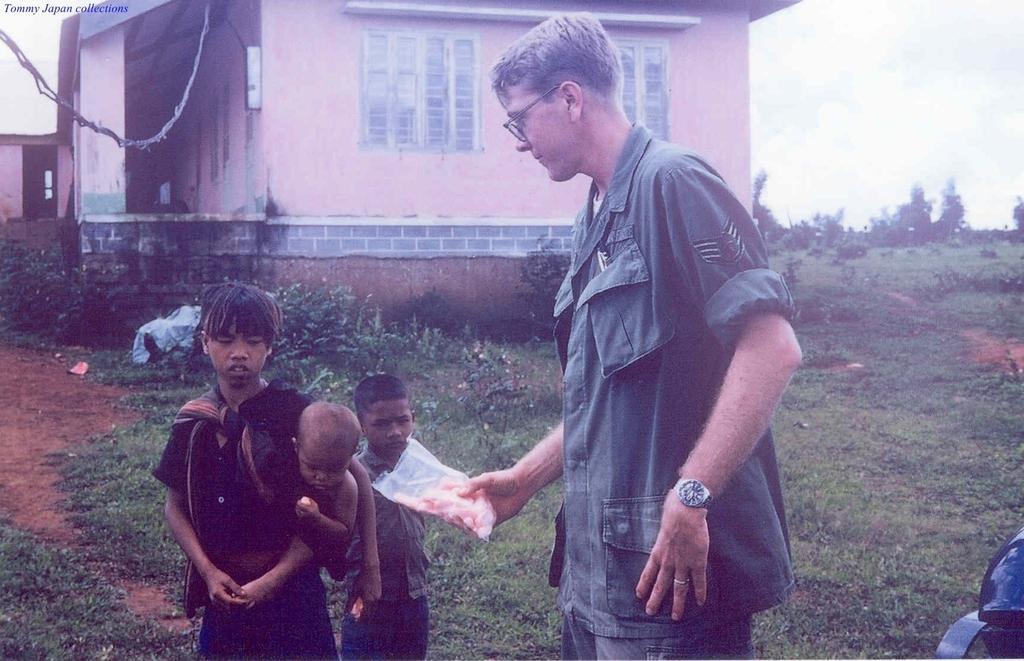Describe this image in one or two sentences. In the image I can see a person who is holding the packet and a boy who is holding the kid and also I can see the other kid, house and some trees and plants. 